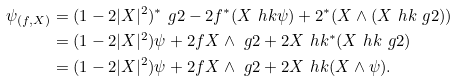<formula> <loc_0><loc_0><loc_500><loc_500>\psi _ { ( f , X ) } & = ( 1 - 2 | X | ^ { 2 } ) ^ { * } \ g 2 - 2 f ^ { * } ( X \ h k \psi ) + 2 ^ { * } ( X \wedge ( X \ h k \ g 2 ) ) \\ & = ( 1 - 2 | X | ^ { 2 } ) \psi + 2 f X \wedge \ g 2 + 2 X \ h k ^ { * } ( X \ h k \ g 2 ) \\ & = ( 1 - 2 | X | ^ { 2 } ) \psi + 2 f X \wedge \ g 2 + 2 X \ h k ( X \wedge \psi ) .</formula> 